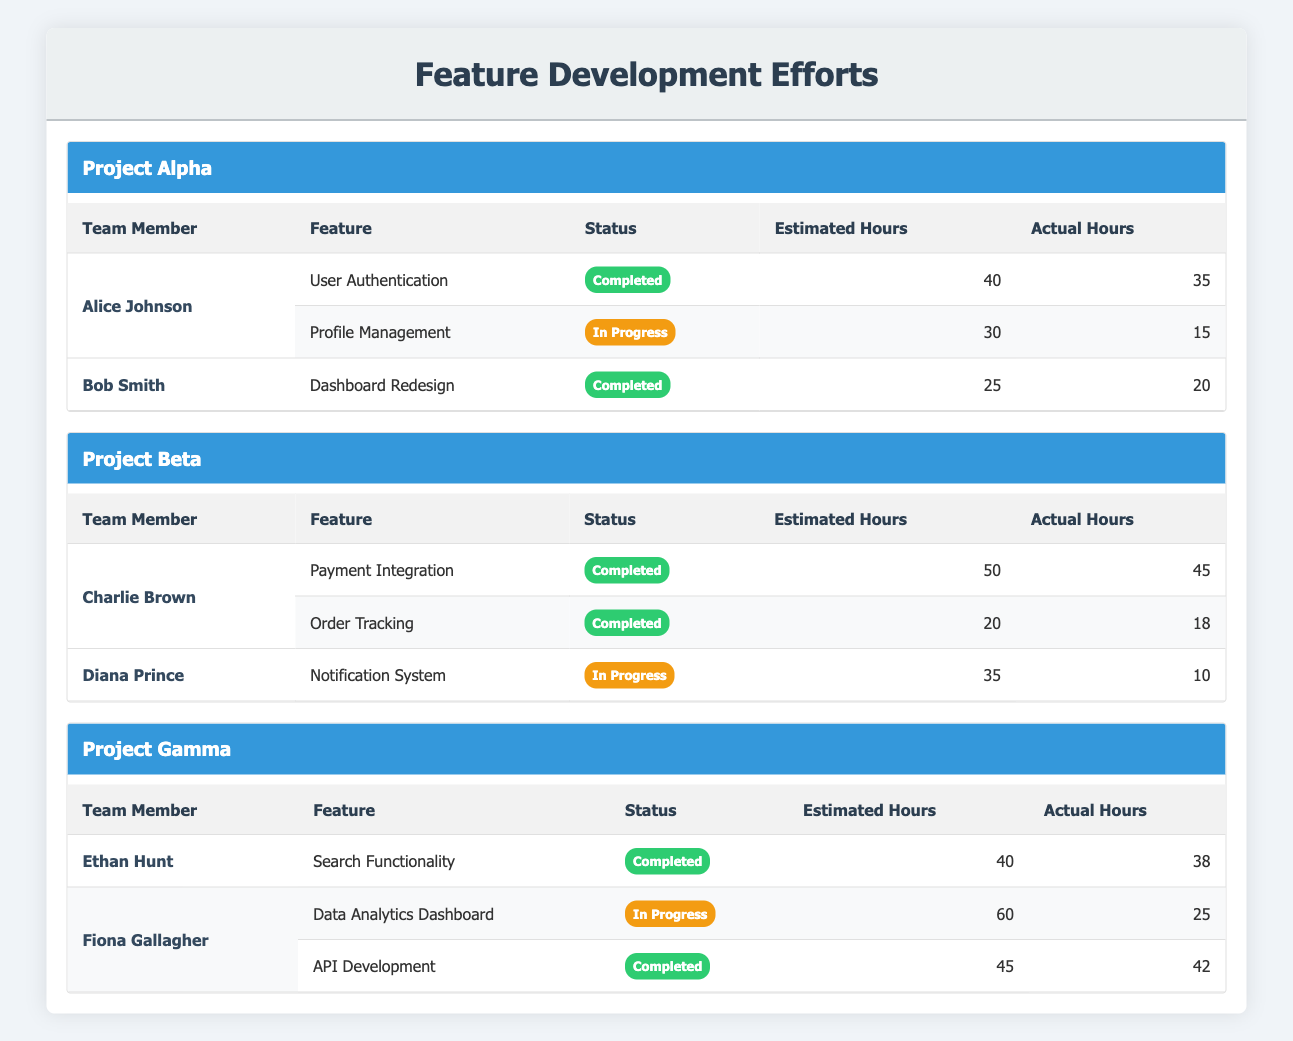What is the total number of completed features across all projects? To find the total number of completed features, I can count the number of features marked as "Completed" from each project. In Project Alpha, there are 2 completed features. In Project Beta, there are 2 completed features. In Project Gamma, there is 1 completed feature. Adding these gives 2 + 2 + 1 = 5 completed features in total.
Answer: 5 Which team member has the highest actual hours worked on completed features? I will compare the actual hours worked on completed features by each team member. Alice Johnson: 35 hours, Bob Smith: 20 hours, Charlie Brown: 45 hours, Ethan Hunt: 38 hours, and Fiona Gallagher: 42 hours. The highest is Charlie Brown with 45 actual hours.
Answer: Charlie Brown Is there anyone who has not completed any features? To determine if any team members have not completed features, I will check the status of each feature for each member. Alice Johnson has completed features, Bob Smith has completed features, Charlie Brown has completed features, Ethan Hunt has completed features, but Fiona Gallagher has one completed feature and one in-progress feature. Diana Prince has only one in-progress feature. Therefore, yes, Diana Prince has not completed any features.
Answer: Yes What is the average estimated hours for all in-progress features? First, I will identify the estimated hours for all in-progress features: Alice Johnson's Profile Management (30 hours), Diana Prince's Notification System (35 hours), and Fiona Gallagher's Data Analytics Dashboard (60 hours). The sum is 30 + 35 + 60 = 125 hours. Since there are 3 in-progress features, the average is 125 / 3 ≈ 41.67 hours.
Answer: 41.67 Which project has the lowest total estimated hours for its completed features? I will calculate the total estimated hours of completed features for each project. For Project Alpha: 40 hours (Alice) + 25 hours (Bob) = 65 hours. Project Beta: 50 hours (Charlie) + 20 hours (Charlie) = 70 hours. Project Gamma: 40 hours (Ethan) + 45 hours (Fiona) = 85 hours. Project Alpha has the lowest total estimated hours at 65 hours.
Answer: Project Alpha 